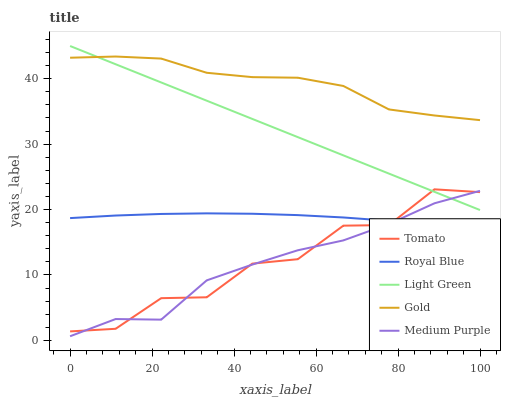Does Medium Purple have the minimum area under the curve?
Answer yes or no. Yes. Does Gold have the maximum area under the curve?
Answer yes or no. Yes. Does Royal Blue have the minimum area under the curve?
Answer yes or no. No. Does Royal Blue have the maximum area under the curve?
Answer yes or no. No. Is Light Green the smoothest?
Answer yes or no. Yes. Is Tomato the roughest?
Answer yes or no. Yes. Is Royal Blue the smoothest?
Answer yes or no. No. Is Royal Blue the roughest?
Answer yes or no. No. Does Medium Purple have the lowest value?
Answer yes or no. Yes. Does Royal Blue have the lowest value?
Answer yes or no. No. Does Light Green have the highest value?
Answer yes or no. Yes. Does Medium Purple have the highest value?
Answer yes or no. No. Is Tomato less than Gold?
Answer yes or no. Yes. Is Light Green greater than Royal Blue?
Answer yes or no. Yes. Does Gold intersect Light Green?
Answer yes or no. Yes. Is Gold less than Light Green?
Answer yes or no. No. Is Gold greater than Light Green?
Answer yes or no. No. Does Tomato intersect Gold?
Answer yes or no. No. 